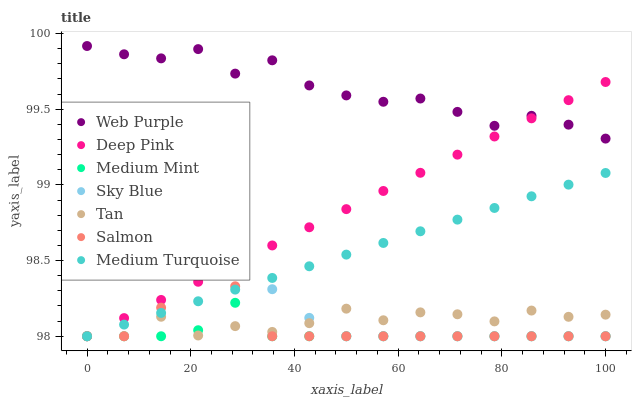Does Medium Mint have the minimum area under the curve?
Answer yes or no. Yes. Does Web Purple have the maximum area under the curve?
Answer yes or no. Yes. Does Deep Pink have the minimum area under the curve?
Answer yes or no. No. Does Deep Pink have the maximum area under the curve?
Answer yes or no. No. Is Medium Turquoise the smoothest?
Answer yes or no. Yes. Is Tan the roughest?
Answer yes or no. Yes. Is Deep Pink the smoothest?
Answer yes or no. No. Is Deep Pink the roughest?
Answer yes or no. No. Does Medium Mint have the lowest value?
Answer yes or no. Yes. Does Web Purple have the lowest value?
Answer yes or no. No. Does Web Purple have the highest value?
Answer yes or no. Yes. Does Deep Pink have the highest value?
Answer yes or no. No. Is Medium Turquoise less than Web Purple?
Answer yes or no. Yes. Is Web Purple greater than Medium Turquoise?
Answer yes or no. Yes. Does Salmon intersect Sky Blue?
Answer yes or no. Yes. Is Salmon less than Sky Blue?
Answer yes or no. No. Is Salmon greater than Sky Blue?
Answer yes or no. No. Does Medium Turquoise intersect Web Purple?
Answer yes or no. No. 